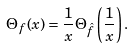Convert formula to latex. <formula><loc_0><loc_0><loc_500><loc_500>\Theta _ { f } ( x ) = \frac { 1 } { x } \Theta _ { \hat { f } } \left ( \frac { 1 } { x } \right ) .</formula> 